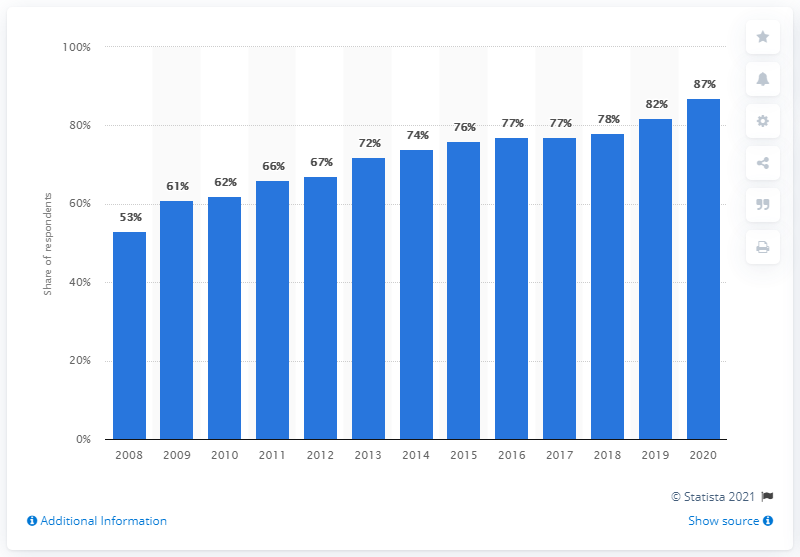Point out several critical features in this image. According to a survey conducted in 2020, 87% of British consumers reported using online channels to make purchases. 